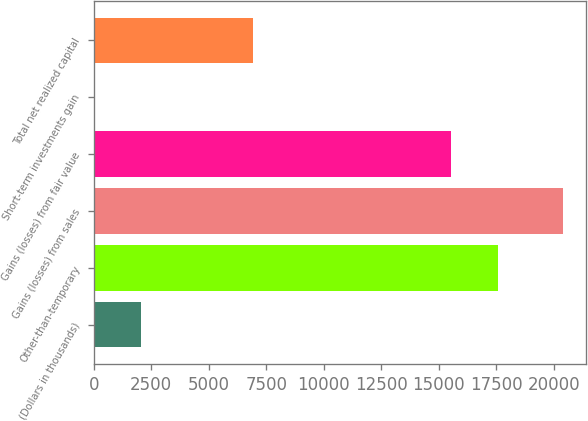Convert chart to OTSL. <chart><loc_0><loc_0><loc_500><loc_500><bar_chart><fcel>(Dollars in thousands)<fcel>Other-than-temporary<fcel>Gains (losses) from sales<fcel>Gains (losses) from fair value<fcel>Short-term investments gain<fcel>Total net realized capital<nl><fcel>2039.6<fcel>17555.6<fcel>20378<fcel>15518<fcel>2<fcel>6923<nl></chart> 